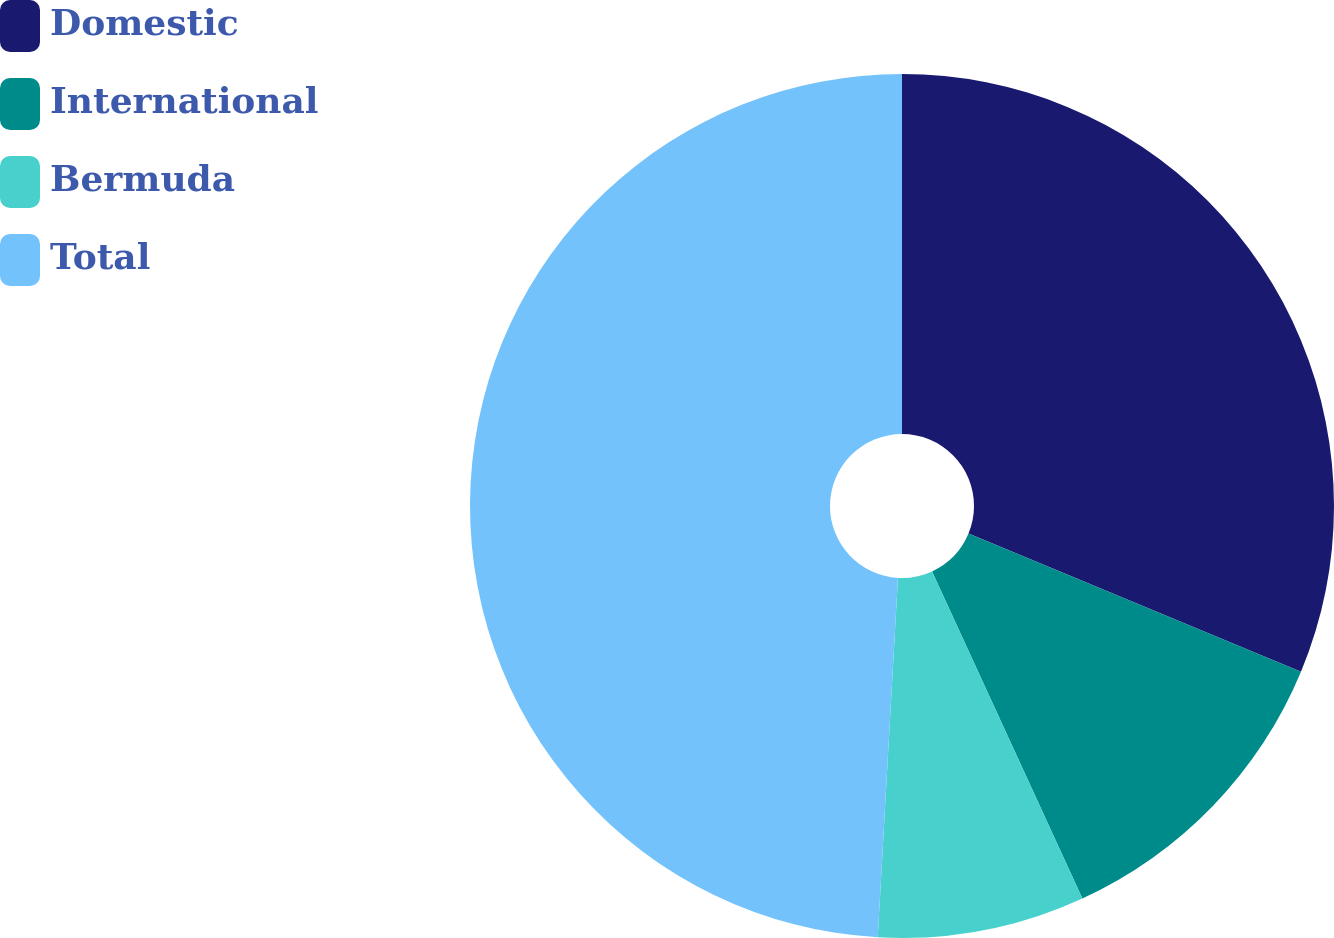Convert chart to OTSL. <chart><loc_0><loc_0><loc_500><loc_500><pie_chart><fcel>Domestic<fcel>International<fcel>Bermuda<fcel>Total<nl><fcel>31.26%<fcel>11.88%<fcel>7.75%<fcel>49.1%<nl></chart> 